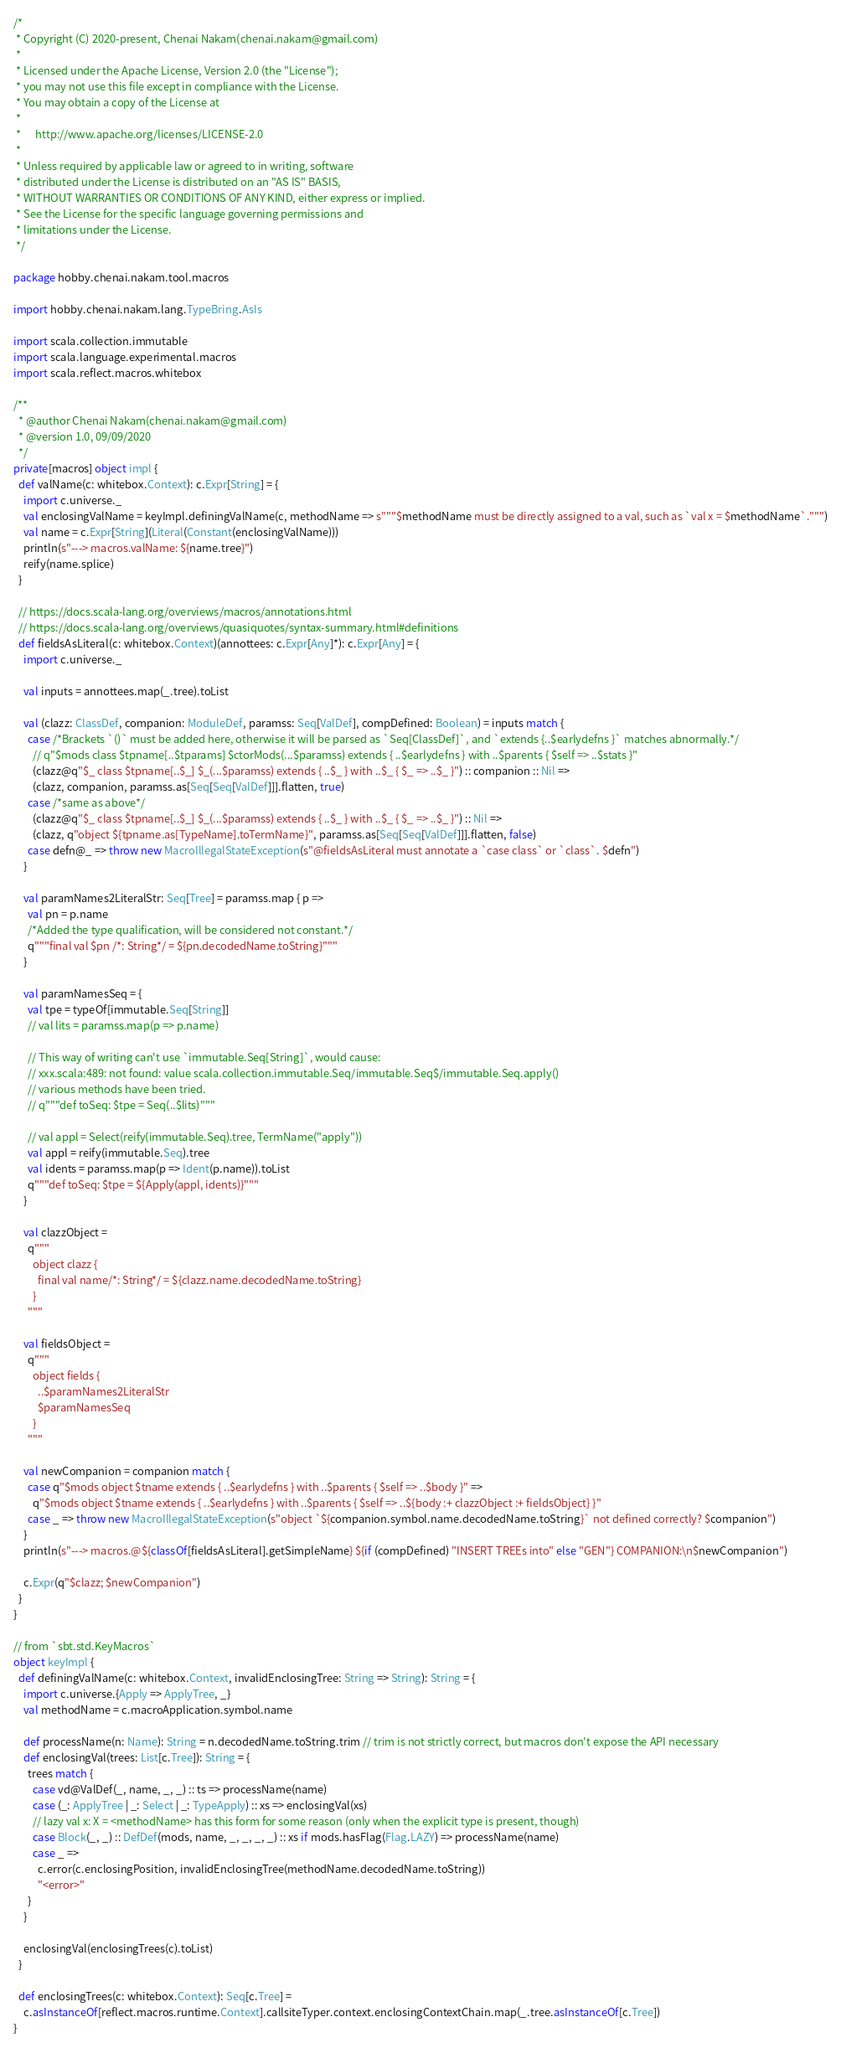Convert code to text. <code><loc_0><loc_0><loc_500><loc_500><_Scala_>/*
 * Copyright (C) 2020-present, Chenai Nakam(chenai.nakam@gmail.com)
 *
 * Licensed under the Apache License, Version 2.0 (the "License");
 * you may not use this file except in compliance with the License.
 * You may obtain a copy of the License at
 *
 *      http://www.apache.org/licenses/LICENSE-2.0
 *
 * Unless required by applicable law or agreed to in writing, software
 * distributed under the License is distributed on an "AS IS" BASIS,
 * WITHOUT WARRANTIES OR CONDITIONS OF ANY KIND, either express or implied.
 * See the License for the specific language governing permissions and
 * limitations under the License.
 */

package hobby.chenai.nakam.tool.macros

import hobby.chenai.nakam.lang.TypeBring.AsIs

import scala.collection.immutable
import scala.language.experimental.macros
import scala.reflect.macros.whitebox

/**
  * @author Chenai Nakam(chenai.nakam@gmail.com)
  * @version 1.0, 09/09/2020
  */
private[macros] object impl {
  def valName(c: whitebox.Context): c.Expr[String] = {
    import c.universe._
    val enclosingValName = keyImpl.definingValName(c, methodName => s"""$methodName must be directly assigned to a val, such as `val x = $methodName`.""")
    val name = c.Expr[String](Literal(Constant(enclosingValName)))
    println(s"---> macros.valName: ${name.tree}")
    reify(name.splice)
  }

  // https://docs.scala-lang.org/overviews/macros/annotations.html
  // https://docs.scala-lang.org/overviews/quasiquotes/syntax-summary.html#definitions
  def fieldsAsLiteral(c: whitebox.Context)(annottees: c.Expr[Any]*): c.Expr[Any] = {
    import c.universe._

    val inputs = annottees.map(_.tree).toList

    val (clazz: ClassDef, companion: ModuleDef, paramss: Seq[ValDef], compDefined: Boolean) = inputs match {
      case /*Brackets `()` must be added here, otherwise it will be parsed as `Seq[ClassDef]`, and `extends {..$earlydefns }` matches abnormally.*/
        // q"$mods class $tpname[..$tparams] $ctorMods(...$paramss) extends { ..$earlydefns } with ..$parents { $self => ..$stats }"
        (clazz@q"$_ class $tpname[..$_] $_(...$paramss) extends { ..$_ } with ..$_ { $_ => ..$_ }") :: companion :: Nil =>
        (clazz, companion, paramss.as[Seq[Seq[ValDef]]].flatten, true)
      case /*same as above*/
        (clazz@q"$_ class $tpname[..$_] $_(...$paramss) extends { ..$_ } with ..$_ { $_ => ..$_ }") :: Nil =>
        (clazz, q"object ${tpname.as[TypeName].toTermName}", paramss.as[Seq[Seq[ValDef]]].flatten, false)
      case defn@_ => throw new MacroIllegalStateException(s"@fieldsAsLiteral must annotate a `case class` or `class`. $defn")
    }

    val paramNames2LiteralStr: Seq[Tree] = paramss.map { p =>
      val pn = p.name
      /*Added the type qualification, will be considered not constant.*/
      q"""final val $pn /*: String*/ = ${pn.decodedName.toString}"""
    }

    val paramNamesSeq = {
      val tpe = typeOf[immutable.Seq[String]]
      // val lits = paramss.map(p => p.name)

      // This way of writing can't use `immutable.Seq[String]`, would cause:
      // xxx.scala:489: not found: value scala.collection.immutable.Seq/immutable.Seq$/immutable.Seq.apply()
      // various methods have been tried.
      // q"""def toSeq: $tpe = Seq(..$lits)"""

      // val appl = Select(reify(immutable.Seq).tree, TermName("apply"))
      val appl = reify(immutable.Seq).tree
      val idents = paramss.map(p => Ident(p.name)).toList
      q"""def toSeq: $tpe = ${Apply(appl, idents)}"""
    }

    val clazzObject =
      q"""
        object clazz {
          final val name/*: String*/ = ${clazz.name.decodedName.toString}
        }
      """

    val fieldsObject =
      q"""
        object fields {
          ..$paramNames2LiteralStr
          $paramNamesSeq
        }
      """

    val newCompanion = companion match {
      case q"$mods object $tname extends { ..$earlydefns } with ..$parents { $self => ..$body }" =>
        q"$mods object $tname extends { ..$earlydefns } with ..$parents { $self => ..${body :+ clazzObject :+ fieldsObject} }"
      case _ => throw new MacroIllegalStateException(s"object `${companion.symbol.name.decodedName.toString}` not defined correctly? $companion")
    }
    println(s"---> macros.@${classOf[fieldsAsLiteral].getSimpleName} ${if (compDefined) "INSERT TREEs into" else "GEN"} COMPANION:\n$newCompanion")

    c.Expr(q"$clazz; $newCompanion")
  }
}

// from `sbt.std.KeyMacros`
object keyImpl {
  def definingValName(c: whitebox.Context, invalidEnclosingTree: String => String): String = {
    import c.universe.{Apply => ApplyTree, _}
    val methodName = c.macroApplication.symbol.name

    def processName(n: Name): String = n.decodedName.toString.trim // trim is not strictly correct, but macros don't expose the API necessary
    def enclosingVal(trees: List[c.Tree]): String = {
      trees match {
        case vd@ValDef(_, name, _, _) :: ts => processName(name)
        case (_: ApplyTree | _: Select | _: TypeApply) :: xs => enclosingVal(xs)
        // lazy val x: X = <methodName> has this form for some reason (only when the explicit type is present, though)
        case Block(_, _) :: DefDef(mods, name, _, _, _, _) :: xs if mods.hasFlag(Flag.LAZY) => processName(name)
        case _ =>
          c.error(c.enclosingPosition, invalidEnclosingTree(methodName.decodedName.toString))
          "<error>"
      }
    }

    enclosingVal(enclosingTrees(c).toList)
  }

  def enclosingTrees(c: whitebox.Context): Seq[c.Tree] =
    c.asInstanceOf[reflect.macros.runtime.Context].callsiteTyper.context.enclosingContextChain.map(_.tree.asInstanceOf[c.Tree])
}</code> 